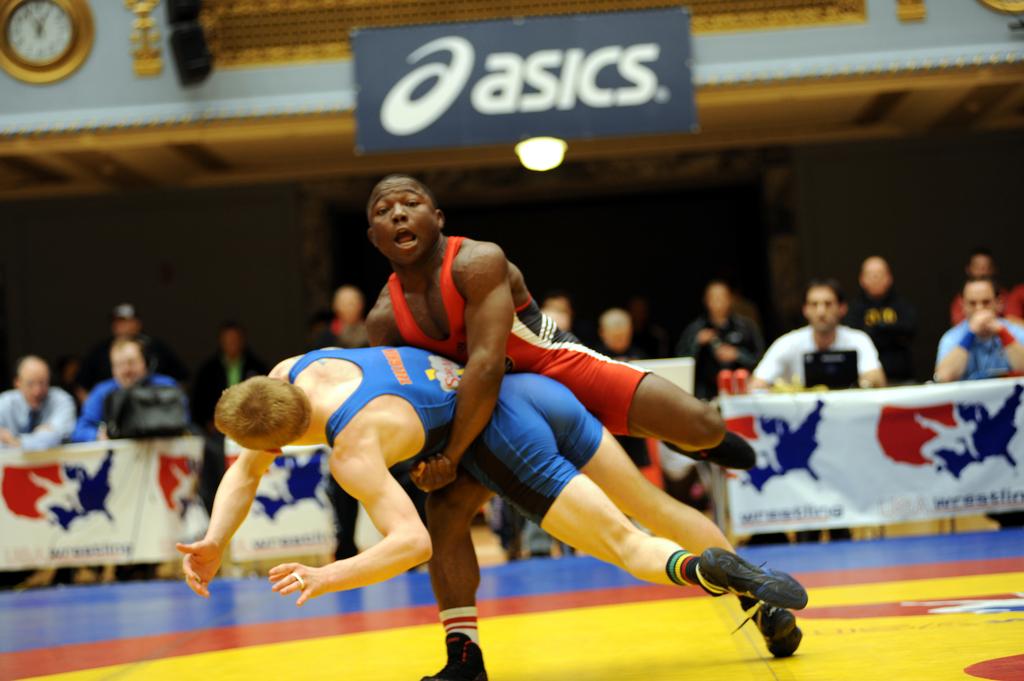What is the name of the advertiser above the wrestlers?
Offer a terse response. Asics. What time is on the clock?
Keep it short and to the point. Unanswerable. 